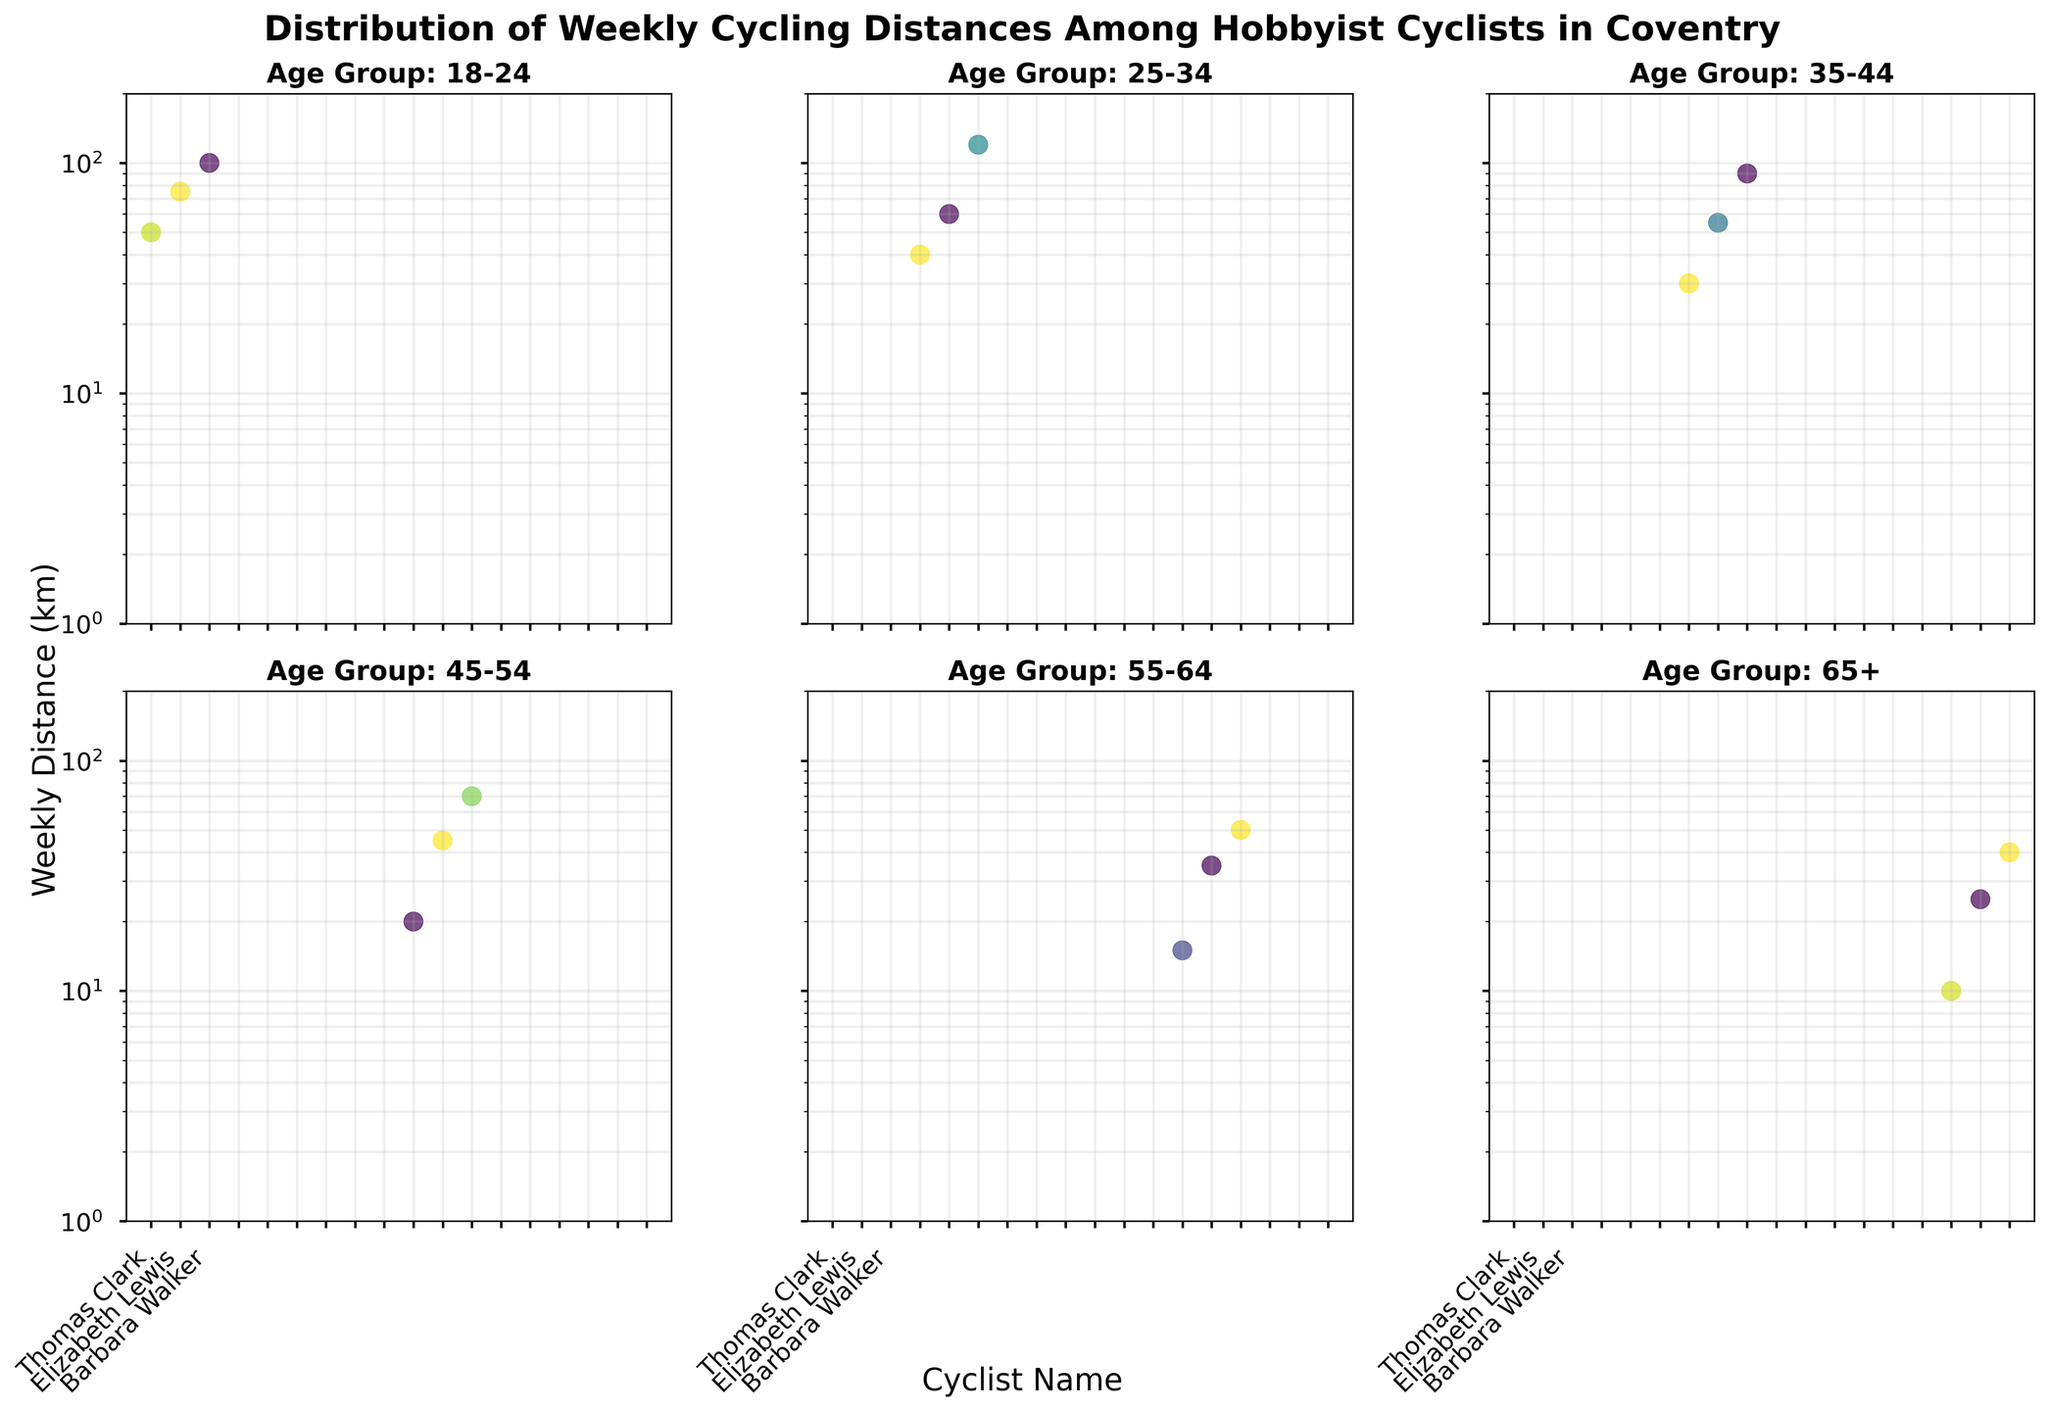How many age groups are represented in the figure? By counting the titles of each subplot, we see that there are six age groups represented in the figure. Each subplot has a distinct title that corresponds to an age group.
Answer: 6 Which age group has the highest maximum weekly cycling distance? By inspecting the subplots, we find that the age group 25-34 has the maximum weekly cycling distance of 120 km.
Answer: 25-34 What is the title of the subplot containing the cyclist with the lowest weekly distance? The cyclist with the lowest weekly distance is in the subplot titled "Age Group: 65+" with a distance of 10 km.
Answer: Age Group: 65+ How many cyclists in the 35-44 age group cycle more than 50 km weekly? In the subplot for the age group 35-44, there are two cyclists (Sarah Miller and Joshua Anderson) who cycle more than 50 km weekly.
Answer: 2 What is the log scale range of the y-axis used in the figure? The y-axis is set to a logarithmic scale ranging from 1 km to 200 km, as indicated by the y-axis labels and grid lines.
Answer: 1 km to 200 km Which cyclist among all age groups cycles exactly 50 km weekly? By examining all the subplots, we see that Michael Johnson from the 18-24 age group and Mark Harris from the 55-64 age group each cycle exactly 50 km weekly.
Answer: Michael Johnson and Mark Harris In the 45-54 age group, what is the difference between the highest and lowest weekly cycling distances? The highest distance is 70 km (Patricia Moore) and the lowest is 20 km (Jessica Martinez). The difference is calculated as 70 km - 20 km.
Answer: 50 km Compare the median weekly cycling distance of the 18-24 and 45-54 age groups. Which age group has a higher median? For the 18-24 age group, the distances are 50 km, 75 km, and 100 km, with a median of 75 km. For the 45-54 age group, the distances are 20 km, 45 km, and 70 km, with a median of 45 km. The 18-24 age group has a higher median.
Answer: 18-24 Which cyclist in the 65+ age group has the highest weekly cycling distance? By looking at the subplot for the age group 65+, we see that Barbara Walker has the highest weekly distance of 40 km.
Answer: Barbara Walker 